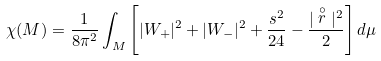<formula> <loc_0><loc_0><loc_500><loc_500>\chi ( M ) = \frac { 1 } { 8 \pi ^ { 2 } } \int _ { M } \left [ | W _ { + } | ^ { 2 } + | W _ { - } | ^ { 2 } + \frac { s ^ { 2 } } { 2 4 } - \frac { | \stackrel { \circ } { r } | ^ { 2 } } { 2 } \right ] d \mu</formula> 